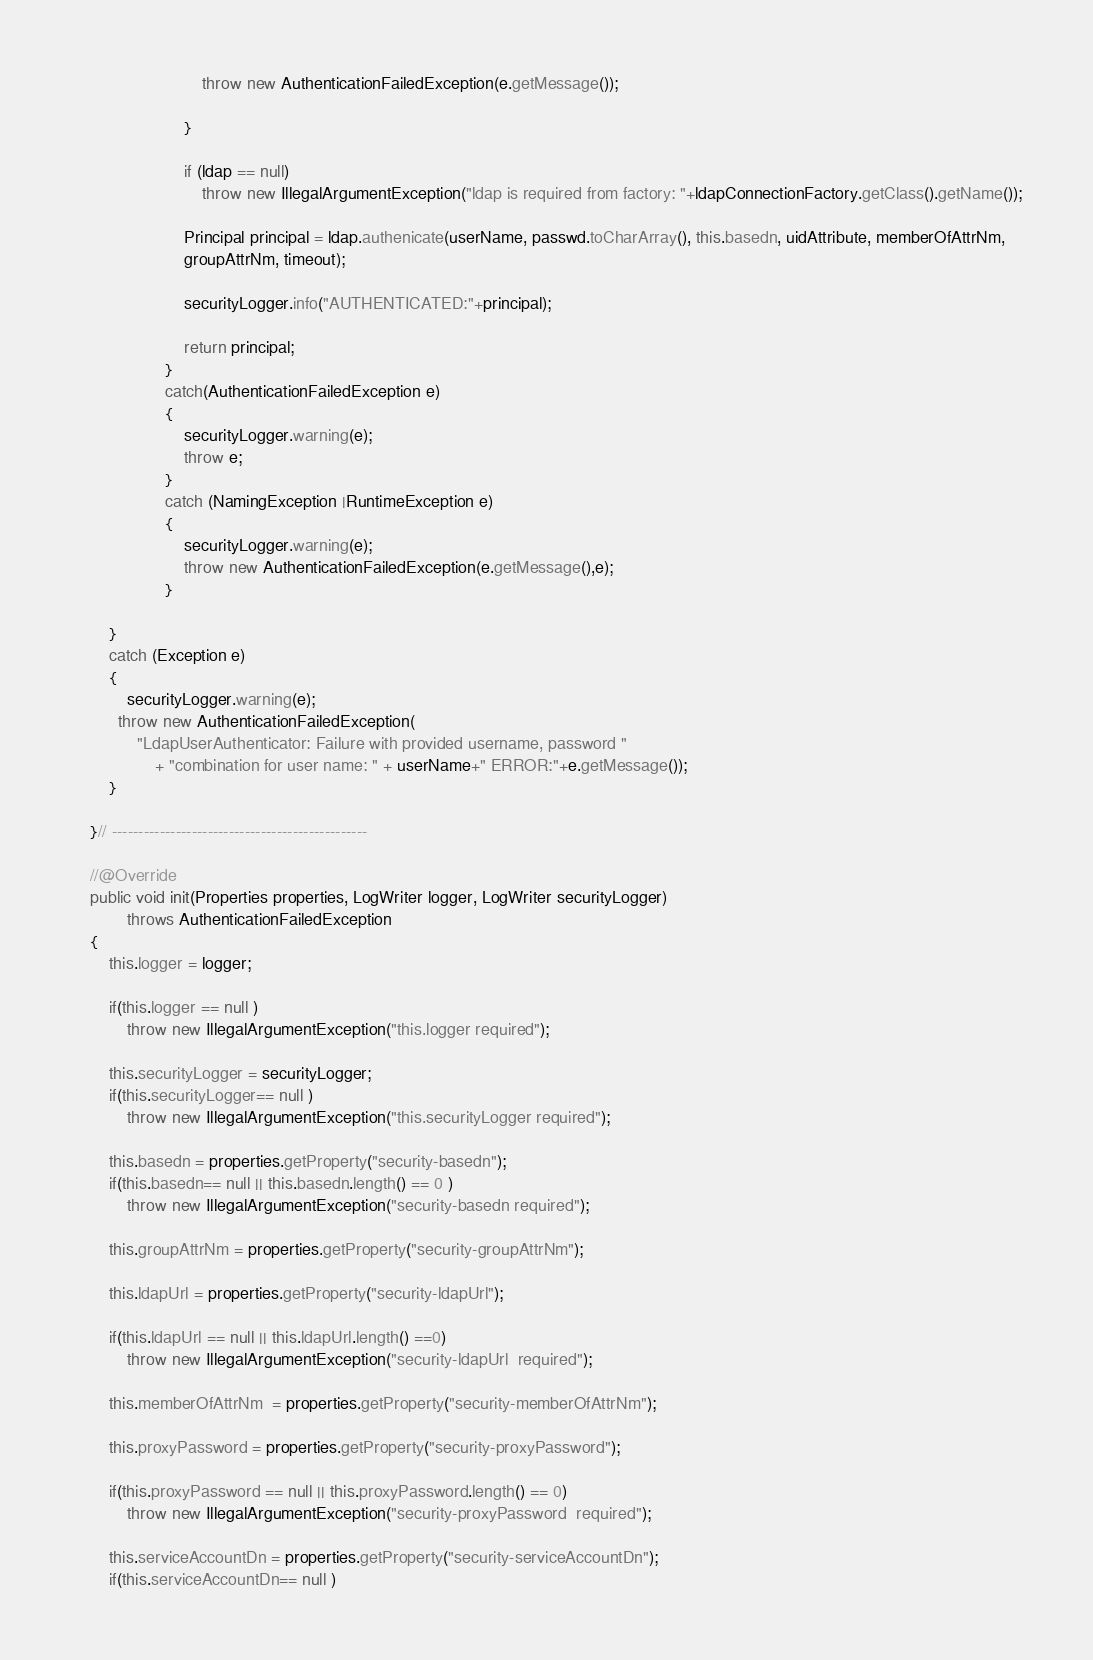<code> <loc_0><loc_0><loc_500><loc_500><_Java_>		    				throw new AuthenticationFailedException(e.getMessage());
		    			
		    			}
		    		
		    			if (ldap == null)
		    				throw new IllegalArgumentException("ldap is required from factory: "+ldapConnectionFactory.getClass().getName());
		    			
		    			Principal principal = ldap.authenicate(userName, passwd.toCharArray(), this.basedn, uidAttribute, memberOfAttrNm,
		    			groupAttrNm, timeout);
		    			
		    			securityLogger.info("AUTHENTICATED:"+principal);
		    			
		    			return principal;
		    		}
		    		catch(AuthenticationFailedException e)
		    		{
		    			securityLogger.warning(e);
		    			throw e;
		    		}
		    		catch (NamingException |RuntimeException e)
		    		{
		    			securityLogger.warning(e);
		    			throw new AuthenticationFailedException(e.getMessage(),e);
		    		}
		 
	    }
	    catch (Exception e) 
	    {
	    	securityLogger.warning(e);
	      throw new AuthenticationFailedException(
	          "LdapUserAuthenticator: Failure with provided username, password "
	              + "combination for user name: " + userName+" ERROR:"+e.getMessage());
	    }
	    
	}// ------------------------------------------------

	//@Override
	public void init(Properties properties, LogWriter logger, LogWriter securityLogger)
			throws AuthenticationFailedException
	{
		this.logger = logger;
		
		if(this.logger == null )
			throw new IllegalArgumentException("this.logger required");
		
		this.securityLogger = securityLogger;
		if(this.securityLogger== null )
			throw new IllegalArgumentException("this.securityLogger required");
		
		this.basedn = properties.getProperty("security-basedn");
		if(this.basedn== null || this.basedn.length() == 0 )
			throw new IllegalArgumentException("security-basedn required");
		
		this.groupAttrNm = properties.getProperty("security-groupAttrNm");
		
		this.ldapUrl = properties.getProperty("security-ldapUrl");
		
		if(this.ldapUrl == null || this.ldapUrl.length() ==0)
			throw new IllegalArgumentException("security-ldapUrl  required");
		
		this.memberOfAttrNm  = properties.getProperty("security-memberOfAttrNm");
		
		this.proxyPassword = properties.getProperty("security-proxyPassword");
		
		if(this.proxyPassword == null || this.proxyPassword.length() == 0)
			throw new IllegalArgumentException("security-proxyPassword  required");
		
		this.serviceAccountDn = properties.getProperty("security-serviceAccountDn");
		if(this.serviceAccountDn== null )</code> 